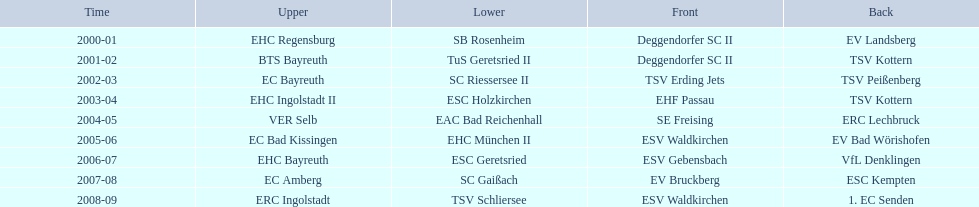What is the number of seasons covered in the table? 9. 